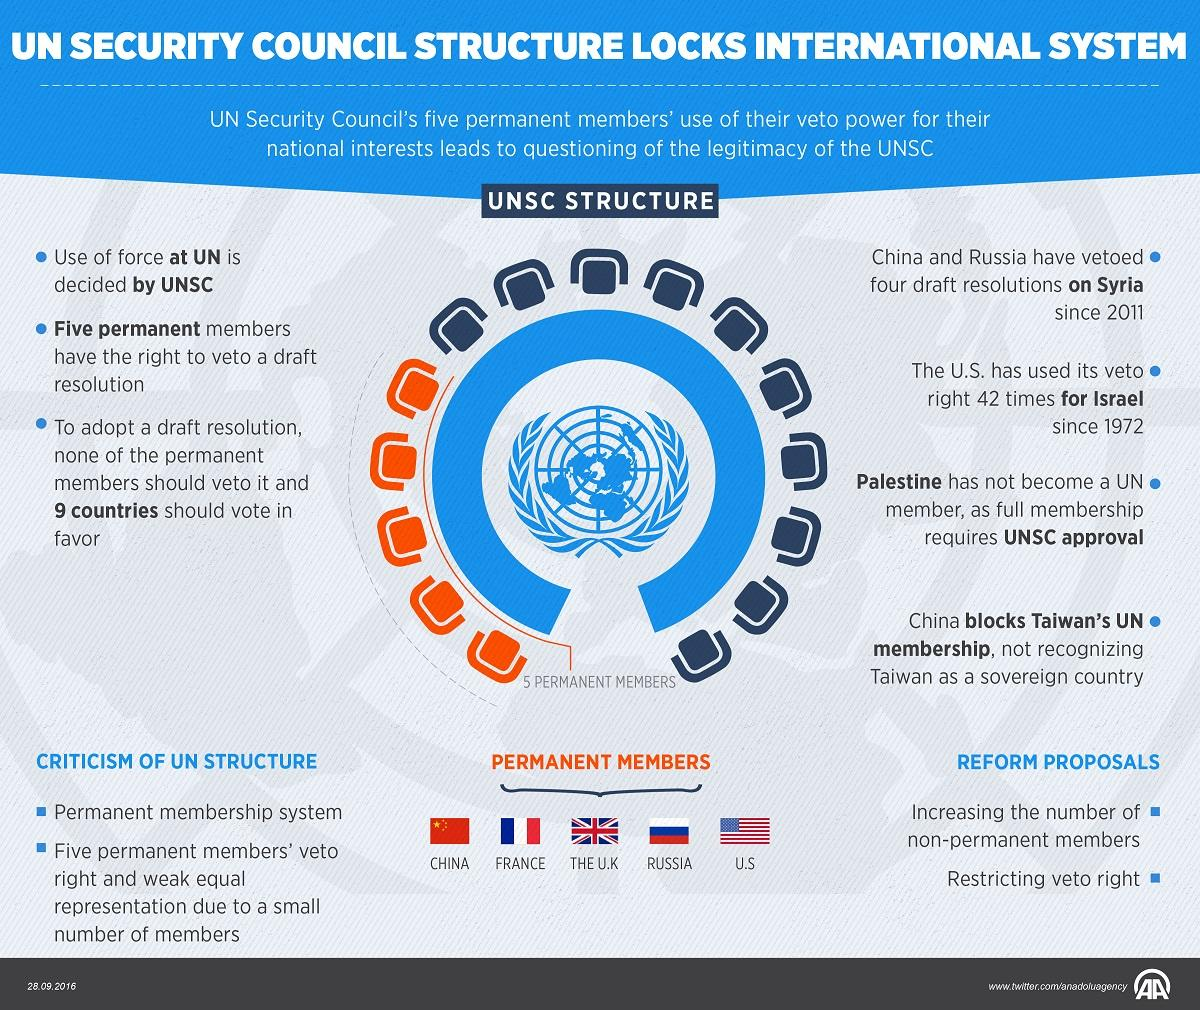Point out several critical features in this image. There are 5 permanent members in the United Nations. Ten non-permanent member seats have been reserved. The Chinese, Russian, and American governments have used their veto power to protect their national interests. 